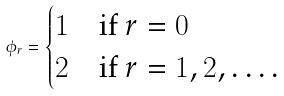Convert formula to latex. <formula><loc_0><loc_0><loc_500><loc_500>\phi _ { r } = \begin{cases} 1 & \text {if $r=0$} \\ 2 & \text {if $r=1,2,\dots$.} \end{cases}</formula> 